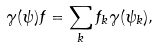<formula> <loc_0><loc_0><loc_500><loc_500>\gamma ( \psi ) f = \sum _ { k } f _ { k } \gamma ( \psi _ { k } ) ,</formula> 